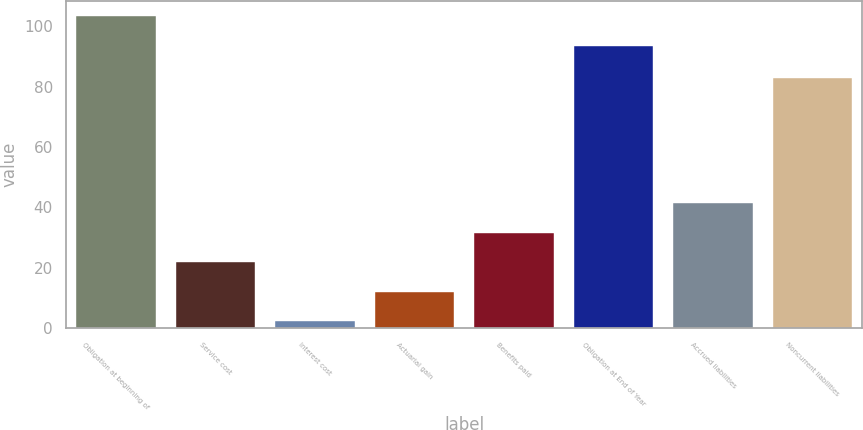Convert chart. <chart><loc_0><loc_0><loc_500><loc_500><bar_chart><fcel>Obligation at beginning of<fcel>Service cost<fcel>Interest cost<fcel>Actuarial gain<fcel>Benefits paid<fcel>Obligation at End of Year<fcel>Accrued liabilities<fcel>Noncurrent liabilities<nl><fcel>103.26<fcel>21.82<fcel>2.3<fcel>12.06<fcel>31.58<fcel>93.5<fcel>41.34<fcel>82.8<nl></chart> 